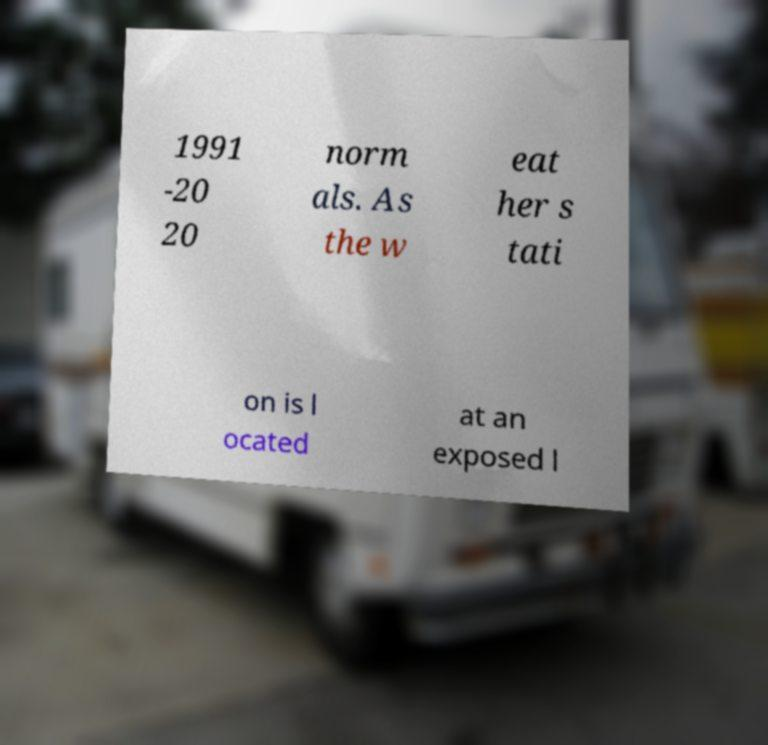What messages or text are displayed in this image? I need them in a readable, typed format. 1991 -20 20 norm als. As the w eat her s tati on is l ocated at an exposed l 